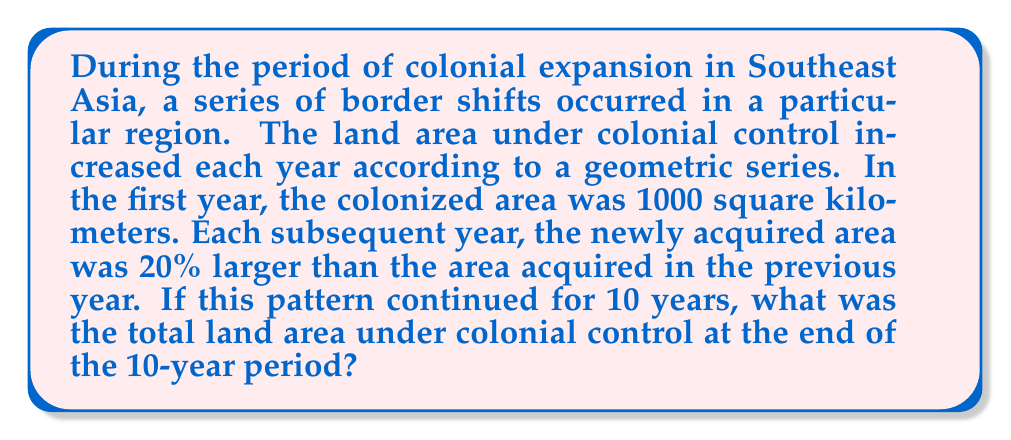Teach me how to tackle this problem. Let's approach this step-by-step using the properties of geometric series:

1) First, we need to identify the components of our geometric series:
   - Initial term (a): 1000 sq km
   - Common ratio (r): 1.20 (20% increase each year means multiplying by 1.20)
   - Number of terms (n): 10 years

2) The formula for the sum of a geometric series is:

   $$ S_n = a\frac{1-r^n}{1-r} $$

   where $S_n$ is the sum of n terms, a is the first term, and r is the common ratio.

3) Substituting our values:

   $$ S_{10} = 1000\frac{1-1.20^{10}}{1-1.20} $$

4) Let's calculate $1.20^{10}$:
   
   $1.20^{10} \approx 6.1917$

5) Now we can solve:

   $$ S_{10} = 1000\frac{1-6.1917}{1-1.20} = 1000\frac{-5.1917}{-0.20} $$

6) Simplifying:

   $$ S_{10} = 1000 * 25.9585 = 25,958.5 $$

7) Therefore, the total land area under colonial control after 10 years would be 25,958.5 square kilometers.
Answer: The total land area under colonial control after 10 years would be approximately 25,958.5 square kilometers. 